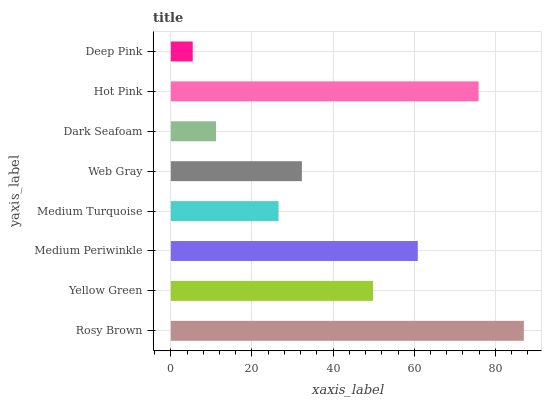Is Deep Pink the minimum?
Answer yes or no. Yes. Is Rosy Brown the maximum?
Answer yes or no. Yes. Is Yellow Green the minimum?
Answer yes or no. No. Is Yellow Green the maximum?
Answer yes or no. No. Is Rosy Brown greater than Yellow Green?
Answer yes or no. Yes. Is Yellow Green less than Rosy Brown?
Answer yes or no. Yes. Is Yellow Green greater than Rosy Brown?
Answer yes or no. No. Is Rosy Brown less than Yellow Green?
Answer yes or no. No. Is Yellow Green the high median?
Answer yes or no. Yes. Is Web Gray the low median?
Answer yes or no. Yes. Is Deep Pink the high median?
Answer yes or no. No. Is Deep Pink the low median?
Answer yes or no. No. 